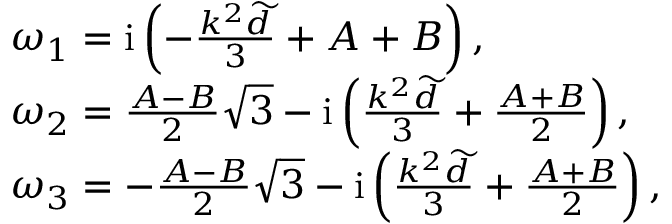Convert formula to latex. <formula><loc_0><loc_0><loc_500><loc_500>\begin{array} { r l } & { \omega _ { 1 } = i \left ( - \frac { k ^ { 2 } \widetilde { d } } { 3 } + A + B \right ) , } \\ & { \omega _ { 2 } = \frac { A - B } { 2 } \sqrt { 3 } - i \left ( \frac { k ^ { 2 } \widetilde { d } } { 3 } + \frac { A + B } { 2 } \right ) , } \\ & { \omega _ { 3 } = - \frac { A - B } { 2 } \sqrt { 3 } - i \left ( \frac { k ^ { 2 } \widetilde { d } } { 3 } + \frac { A + B } { 2 } \right ) , } \end{array}</formula> 